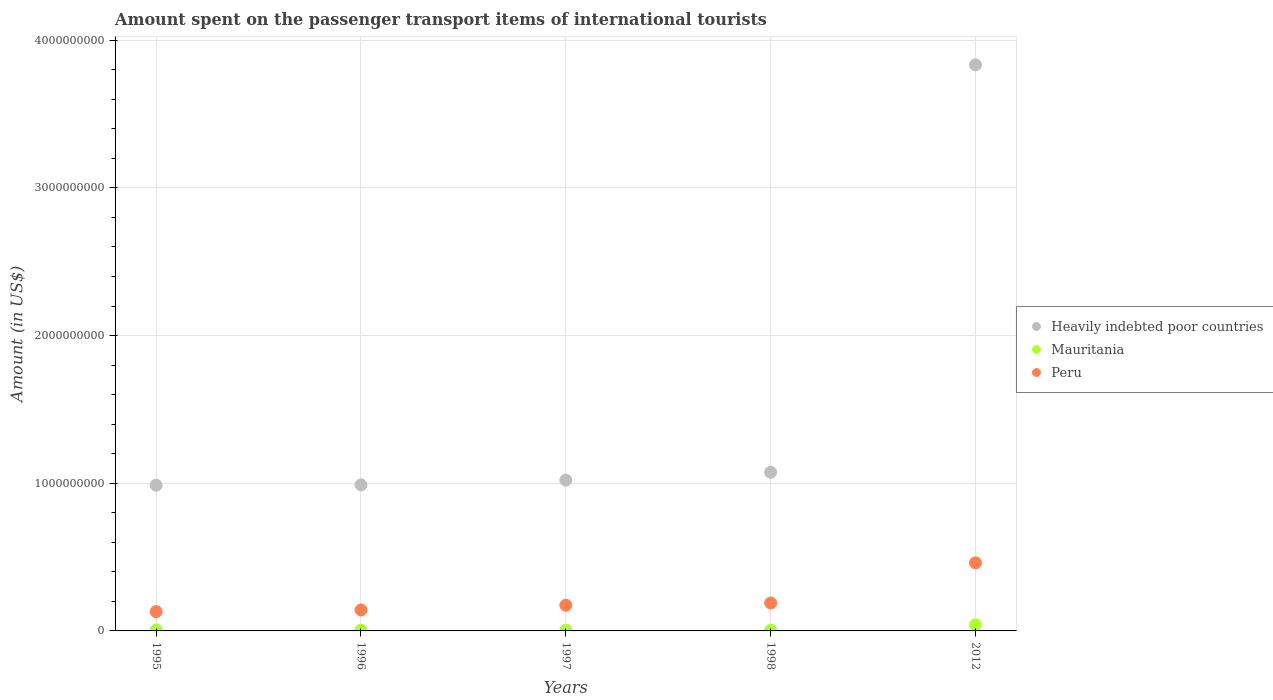How many different coloured dotlines are there?
Offer a terse response. 3. Is the number of dotlines equal to the number of legend labels?
Your answer should be very brief. Yes. What is the amount spent on the passenger transport items of international tourists in Heavily indebted poor countries in 1995?
Make the answer very short. 9.87e+08. Across all years, what is the maximum amount spent on the passenger transport items of international tourists in Mauritania?
Ensure brevity in your answer.  4.20e+07. Across all years, what is the minimum amount spent on the passenger transport items of international tourists in Peru?
Your answer should be compact. 1.31e+08. In which year was the amount spent on the passenger transport items of international tourists in Peru maximum?
Give a very brief answer. 2012. In which year was the amount spent on the passenger transport items of international tourists in Mauritania minimum?
Ensure brevity in your answer.  1996. What is the total amount spent on the passenger transport items of international tourists in Peru in the graph?
Ensure brevity in your answer.  1.10e+09. What is the difference between the amount spent on the passenger transport items of international tourists in Peru in 1995 and that in 1997?
Give a very brief answer. -4.30e+07. What is the difference between the amount spent on the passenger transport items of international tourists in Peru in 1997 and the amount spent on the passenger transport items of international tourists in Heavily indebted poor countries in 2012?
Make the answer very short. -3.66e+09. What is the average amount spent on the passenger transport items of international tourists in Peru per year?
Give a very brief answer. 2.19e+08. In the year 1997, what is the difference between the amount spent on the passenger transport items of international tourists in Peru and amount spent on the passenger transport items of international tourists in Heavily indebted poor countries?
Keep it short and to the point. -8.47e+08. Is the amount spent on the passenger transport items of international tourists in Heavily indebted poor countries in 1995 less than that in 1996?
Your response must be concise. Yes. What is the difference between the highest and the second highest amount spent on the passenger transport items of international tourists in Peru?
Offer a terse response. 2.72e+08. What is the difference between the highest and the lowest amount spent on the passenger transport items of international tourists in Heavily indebted poor countries?
Your response must be concise. 2.85e+09. In how many years, is the amount spent on the passenger transport items of international tourists in Heavily indebted poor countries greater than the average amount spent on the passenger transport items of international tourists in Heavily indebted poor countries taken over all years?
Offer a very short reply. 1. Is the amount spent on the passenger transport items of international tourists in Peru strictly greater than the amount spent on the passenger transport items of international tourists in Heavily indebted poor countries over the years?
Keep it short and to the point. No. How many years are there in the graph?
Offer a very short reply. 5. Are the values on the major ticks of Y-axis written in scientific E-notation?
Your response must be concise. No. Does the graph contain any zero values?
Keep it short and to the point. No. Does the graph contain grids?
Give a very brief answer. Yes. How many legend labels are there?
Give a very brief answer. 3. How are the legend labels stacked?
Keep it short and to the point. Vertical. What is the title of the graph?
Provide a short and direct response. Amount spent on the passenger transport items of international tourists. Does "Sri Lanka" appear as one of the legend labels in the graph?
Offer a very short reply. No. What is the label or title of the X-axis?
Offer a terse response. Years. What is the Amount (in US$) in Heavily indebted poor countries in 1995?
Provide a succinct answer. 9.87e+08. What is the Amount (in US$) in Peru in 1995?
Offer a very short reply. 1.31e+08. What is the Amount (in US$) of Heavily indebted poor countries in 1996?
Your response must be concise. 9.89e+08. What is the Amount (in US$) of Mauritania in 1996?
Provide a short and direct response. 5.00e+06. What is the Amount (in US$) in Peru in 1996?
Provide a succinct answer. 1.42e+08. What is the Amount (in US$) of Heavily indebted poor countries in 1997?
Offer a terse response. 1.02e+09. What is the Amount (in US$) in Peru in 1997?
Ensure brevity in your answer.  1.74e+08. What is the Amount (in US$) of Heavily indebted poor countries in 1998?
Make the answer very short. 1.07e+09. What is the Amount (in US$) of Mauritania in 1998?
Provide a succinct answer. 5.00e+06. What is the Amount (in US$) of Peru in 1998?
Make the answer very short. 1.89e+08. What is the Amount (in US$) of Heavily indebted poor countries in 2012?
Your answer should be very brief. 3.83e+09. What is the Amount (in US$) of Mauritania in 2012?
Your answer should be very brief. 4.20e+07. What is the Amount (in US$) in Peru in 2012?
Your response must be concise. 4.61e+08. Across all years, what is the maximum Amount (in US$) in Heavily indebted poor countries?
Offer a very short reply. 3.83e+09. Across all years, what is the maximum Amount (in US$) of Mauritania?
Provide a short and direct response. 4.20e+07. Across all years, what is the maximum Amount (in US$) in Peru?
Give a very brief answer. 4.61e+08. Across all years, what is the minimum Amount (in US$) in Heavily indebted poor countries?
Offer a terse response. 9.87e+08. Across all years, what is the minimum Amount (in US$) in Peru?
Your answer should be very brief. 1.31e+08. What is the total Amount (in US$) of Heavily indebted poor countries in the graph?
Ensure brevity in your answer.  7.90e+09. What is the total Amount (in US$) of Mauritania in the graph?
Ensure brevity in your answer.  6.40e+07. What is the total Amount (in US$) of Peru in the graph?
Offer a terse response. 1.10e+09. What is the difference between the Amount (in US$) in Heavily indebted poor countries in 1995 and that in 1996?
Ensure brevity in your answer.  -2.44e+06. What is the difference between the Amount (in US$) of Peru in 1995 and that in 1996?
Keep it short and to the point. -1.10e+07. What is the difference between the Amount (in US$) of Heavily indebted poor countries in 1995 and that in 1997?
Keep it short and to the point. -3.46e+07. What is the difference between the Amount (in US$) of Peru in 1995 and that in 1997?
Provide a succinct answer. -4.30e+07. What is the difference between the Amount (in US$) of Heavily indebted poor countries in 1995 and that in 1998?
Offer a terse response. -8.73e+07. What is the difference between the Amount (in US$) of Mauritania in 1995 and that in 1998?
Your answer should be very brief. 2.00e+06. What is the difference between the Amount (in US$) of Peru in 1995 and that in 1998?
Ensure brevity in your answer.  -5.80e+07. What is the difference between the Amount (in US$) in Heavily indebted poor countries in 1995 and that in 2012?
Provide a short and direct response. -2.85e+09. What is the difference between the Amount (in US$) in Mauritania in 1995 and that in 2012?
Provide a short and direct response. -3.50e+07. What is the difference between the Amount (in US$) in Peru in 1995 and that in 2012?
Provide a short and direct response. -3.30e+08. What is the difference between the Amount (in US$) of Heavily indebted poor countries in 1996 and that in 1997?
Give a very brief answer. -3.21e+07. What is the difference between the Amount (in US$) of Mauritania in 1996 and that in 1997?
Give a very brief answer. 0. What is the difference between the Amount (in US$) of Peru in 1996 and that in 1997?
Provide a short and direct response. -3.20e+07. What is the difference between the Amount (in US$) of Heavily indebted poor countries in 1996 and that in 1998?
Ensure brevity in your answer.  -8.49e+07. What is the difference between the Amount (in US$) of Mauritania in 1996 and that in 1998?
Keep it short and to the point. 0. What is the difference between the Amount (in US$) of Peru in 1996 and that in 1998?
Ensure brevity in your answer.  -4.70e+07. What is the difference between the Amount (in US$) in Heavily indebted poor countries in 1996 and that in 2012?
Offer a terse response. -2.84e+09. What is the difference between the Amount (in US$) in Mauritania in 1996 and that in 2012?
Provide a succinct answer. -3.70e+07. What is the difference between the Amount (in US$) in Peru in 1996 and that in 2012?
Make the answer very short. -3.19e+08. What is the difference between the Amount (in US$) in Heavily indebted poor countries in 1997 and that in 1998?
Your answer should be very brief. -5.28e+07. What is the difference between the Amount (in US$) of Peru in 1997 and that in 1998?
Ensure brevity in your answer.  -1.50e+07. What is the difference between the Amount (in US$) of Heavily indebted poor countries in 1997 and that in 2012?
Provide a short and direct response. -2.81e+09. What is the difference between the Amount (in US$) of Mauritania in 1997 and that in 2012?
Provide a succinct answer. -3.70e+07. What is the difference between the Amount (in US$) of Peru in 1997 and that in 2012?
Offer a very short reply. -2.87e+08. What is the difference between the Amount (in US$) of Heavily indebted poor countries in 1998 and that in 2012?
Ensure brevity in your answer.  -2.76e+09. What is the difference between the Amount (in US$) in Mauritania in 1998 and that in 2012?
Offer a very short reply. -3.70e+07. What is the difference between the Amount (in US$) of Peru in 1998 and that in 2012?
Your answer should be compact. -2.72e+08. What is the difference between the Amount (in US$) in Heavily indebted poor countries in 1995 and the Amount (in US$) in Mauritania in 1996?
Your response must be concise. 9.82e+08. What is the difference between the Amount (in US$) of Heavily indebted poor countries in 1995 and the Amount (in US$) of Peru in 1996?
Your answer should be compact. 8.45e+08. What is the difference between the Amount (in US$) of Mauritania in 1995 and the Amount (in US$) of Peru in 1996?
Make the answer very short. -1.35e+08. What is the difference between the Amount (in US$) in Heavily indebted poor countries in 1995 and the Amount (in US$) in Mauritania in 1997?
Your answer should be very brief. 9.82e+08. What is the difference between the Amount (in US$) of Heavily indebted poor countries in 1995 and the Amount (in US$) of Peru in 1997?
Offer a very short reply. 8.13e+08. What is the difference between the Amount (in US$) of Mauritania in 1995 and the Amount (in US$) of Peru in 1997?
Your answer should be compact. -1.67e+08. What is the difference between the Amount (in US$) in Heavily indebted poor countries in 1995 and the Amount (in US$) in Mauritania in 1998?
Provide a short and direct response. 9.82e+08. What is the difference between the Amount (in US$) in Heavily indebted poor countries in 1995 and the Amount (in US$) in Peru in 1998?
Make the answer very short. 7.98e+08. What is the difference between the Amount (in US$) in Mauritania in 1995 and the Amount (in US$) in Peru in 1998?
Give a very brief answer. -1.82e+08. What is the difference between the Amount (in US$) of Heavily indebted poor countries in 1995 and the Amount (in US$) of Mauritania in 2012?
Ensure brevity in your answer.  9.45e+08. What is the difference between the Amount (in US$) of Heavily indebted poor countries in 1995 and the Amount (in US$) of Peru in 2012?
Your answer should be compact. 5.26e+08. What is the difference between the Amount (in US$) in Mauritania in 1995 and the Amount (in US$) in Peru in 2012?
Your answer should be compact. -4.54e+08. What is the difference between the Amount (in US$) of Heavily indebted poor countries in 1996 and the Amount (in US$) of Mauritania in 1997?
Give a very brief answer. 9.84e+08. What is the difference between the Amount (in US$) of Heavily indebted poor countries in 1996 and the Amount (in US$) of Peru in 1997?
Offer a very short reply. 8.15e+08. What is the difference between the Amount (in US$) in Mauritania in 1996 and the Amount (in US$) in Peru in 1997?
Your answer should be compact. -1.69e+08. What is the difference between the Amount (in US$) in Heavily indebted poor countries in 1996 and the Amount (in US$) in Mauritania in 1998?
Your response must be concise. 9.84e+08. What is the difference between the Amount (in US$) of Heavily indebted poor countries in 1996 and the Amount (in US$) of Peru in 1998?
Provide a short and direct response. 8.00e+08. What is the difference between the Amount (in US$) of Mauritania in 1996 and the Amount (in US$) of Peru in 1998?
Ensure brevity in your answer.  -1.84e+08. What is the difference between the Amount (in US$) of Heavily indebted poor countries in 1996 and the Amount (in US$) of Mauritania in 2012?
Give a very brief answer. 9.47e+08. What is the difference between the Amount (in US$) of Heavily indebted poor countries in 1996 and the Amount (in US$) of Peru in 2012?
Give a very brief answer. 5.28e+08. What is the difference between the Amount (in US$) in Mauritania in 1996 and the Amount (in US$) in Peru in 2012?
Your answer should be very brief. -4.56e+08. What is the difference between the Amount (in US$) of Heavily indebted poor countries in 1997 and the Amount (in US$) of Mauritania in 1998?
Provide a succinct answer. 1.02e+09. What is the difference between the Amount (in US$) in Heavily indebted poor countries in 1997 and the Amount (in US$) in Peru in 1998?
Offer a very short reply. 8.32e+08. What is the difference between the Amount (in US$) of Mauritania in 1997 and the Amount (in US$) of Peru in 1998?
Your response must be concise. -1.84e+08. What is the difference between the Amount (in US$) of Heavily indebted poor countries in 1997 and the Amount (in US$) of Mauritania in 2012?
Offer a terse response. 9.79e+08. What is the difference between the Amount (in US$) in Heavily indebted poor countries in 1997 and the Amount (in US$) in Peru in 2012?
Offer a very short reply. 5.60e+08. What is the difference between the Amount (in US$) of Mauritania in 1997 and the Amount (in US$) of Peru in 2012?
Provide a succinct answer. -4.56e+08. What is the difference between the Amount (in US$) of Heavily indebted poor countries in 1998 and the Amount (in US$) of Mauritania in 2012?
Ensure brevity in your answer.  1.03e+09. What is the difference between the Amount (in US$) in Heavily indebted poor countries in 1998 and the Amount (in US$) in Peru in 2012?
Ensure brevity in your answer.  6.13e+08. What is the difference between the Amount (in US$) of Mauritania in 1998 and the Amount (in US$) of Peru in 2012?
Provide a short and direct response. -4.56e+08. What is the average Amount (in US$) in Heavily indebted poor countries per year?
Ensure brevity in your answer.  1.58e+09. What is the average Amount (in US$) in Mauritania per year?
Keep it short and to the point. 1.28e+07. What is the average Amount (in US$) of Peru per year?
Give a very brief answer. 2.19e+08. In the year 1995, what is the difference between the Amount (in US$) in Heavily indebted poor countries and Amount (in US$) in Mauritania?
Your answer should be very brief. 9.80e+08. In the year 1995, what is the difference between the Amount (in US$) of Heavily indebted poor countries and Amount (in US$) of Peru?
Provide a succinct answer. 8.56e+08. In the year 1995, what is the difference between the Amount (in US$) in Mauritania and Amount (in US$) in Peru?
Ensure brevity in your answer.  -1.24e+08. In the year 1996, what is the difference between the Amount (in US$) in Heavily indebted poor countries and Amount (in US$) in Mauritania?
Your response must be concise. 9.84e+08. In the year 1996, what is the difference between the Amount (in US$) in Heavily indebted poor countries and Amount (in US$) in Peru?
Give a very brief answer. 8.47e+08. In the year 1996, what is the difference between the Amount (in US$) of Mauritania and Amount (in US$) of Peru?
Offer a terse response. -1.37e+08. In the year 1997, what is the difference between the Amount (in US$) in Heavily indebted poor countries and Amount (in US$) in Mauritania?
Ensure brevity in your answer.  1.02e+09. In the year 1997, what is the difference between the Amount (in US$) of Heavily indebted poor countries and Amount (in US$) of Peru?
Provide a short and direct response. 8.47e+08. In the year 1997, what is the difference between the Amount (in US$) of Mauritania and Amount (in US$) of Peru?
Your response must be concise. -1.69e+08. In the year 1998, what is the difference between the Amount (in US$) in Heavily indebted poor countries and Amount (in US$) in Mauritania?
Your response must be concise. 1.07e+09. In the year 1998, what is the difference between the Amount (in US$) of Heavily indebted poor countries and Amount (in US$) of Peru?
Provide a succinct answer. 8.85e+08. In the year 1998, what is the difference between the Amount (in US$) of Mauritania and Amount (in US$) of Peru?
Offer a terse response. -1.84e+08. In the year 2012, what is the difference between the Amount (in US$) of Heavily indebted poor countries and Amount (in US$) of Mauritania?
Your answer should be compact. 3.79e+09. In the year 2012, what is the difference between the Amount (in US$) of Heavily indebted poor countries and Amount (in US$) of Peru?
Your answer should be compact. 3.37e+09. In the year 2012, what is the difference between the Amount (in US$) in Mauritania and Amount (in US$) in Peru?
Your answer should be compact. -4.19e+08. What is the ratio of the Amount (in US$) in Mauritania in 1995 to that in 1996?
Your response must be concise. 1.4. What is the ratio of the Amount (in US$) in Peru in 1995 to that in 1996?
Make the answer very short. 0.92. What is the ratio of the Amount (in US$) in Heavily indebted poor countries in 1995 to that in 1997?
Keep it short and to the point. 0.97. What is the ratio of the Amount (in US$) in Peru in 1995 to that in 1997?
Offer a very short reply. 0.75. What is the ratio of the Amount (in US$) in Heavily indebted poor countries in 1995 to that in 1998?
Provide a short and direct response. 0.92. What is the ratio of the Amount (in US$) in Mauritania in 1995 to that in 1998?
Make the answer very short. 1.4. What is the ratio of the Amount (in US$) in Peru in 1995 to that in 1998?
Provide a short and direct response. 0.69. What is the ratio of the Amount (in US$) in Heavily indebted poor countries in 1995 to that in 2012?
Give a very brief answer. 0.26. What is the ratio of the Amount (in US$) in Mauritania in 1995 to that in 2012?
Make the answer very short. 0.17. What is the ratio of the Amount (in US$) of Peru in 1995 to that in 2012?
Your answer should be compact. 0.28. What is the ratio of the Amount (in US$) in Heavily indebted poor countries in 1996 to that in 1997?
Your answer should be compact. 0.97. What is the ratio of the Amount (in US$) in Mauritania in 1996 to that in 1997?
Provide a short and direct response. 1. What is the ratio of the Amount (in US$) in Peru in 1996 to that in 1997?
Give a very brief answer. 0.82. What is the ratio of the Amount (in US$) of Heavily indebted poor countries in 1996 to that in 1998?
Give a very brief answer. 0.92. What is the ratio of the Amount (in US$) of Mauritania in 1996 to that in 1998?
Provide a succinct answer. 1. What is the ratio of the Amount (in US$) in Peru in 1996 to that in 1998?
Your answer should be compact. 0.75. What is the ratio of the Amount (in US$) of Heavily indebted poor countries in 1996 to that in 2012?
Make the answer very short. 0.26. What is the ratio of the Amount (in US$) of Mauritania in 1996 to that in 2012?
Your answer should be very brief. 0.12. What is the ratio of the Amount (in US$) in Peru in 1996 to that in 2012?
Provide a succinct answer. 0.31. What is the ratio of the Amount (in US$) in Heavily indebted poor countries in 1997 to that in 1998?
Your answer should be compact. 0.95. What is the ratio of the Amount (in US$) in Peru in 1997 to that in 1998?
Make the answer very short. 0.92. What is the ratio of the Amount (in US$) in Heavily indebted poor countries in 1997 to that in 2012?
Give a very brief answer. 0.27. What is the ratio of the Amount (in US$) in Mauritania in 1997 to that in 2012?
Keep it short and to the point. 0.12. What is the ratio of the Amount (in US$) of Peru in 1997 to that in 2012?
Ensure brevity in your answer.  0.38. What is the ratio of the Amount (in US$) of Heavily indebted poor countries in 1998 to that in 2012?
Your response must be concise. 0.28. What is the ratio of the Amount (in US$) of Mauritania in 1998 to that in 2012?
Offer a very short reply. 0.12. What is the ratio of the Amount (in US$) of Peru in 1998 to that in 2012?
Offer a terse response. 0.41. What is the difference between the highest and the second highest Amount (in US$) in Heavily indebted poor countries?
Offer a terse response. 2.76e+09. What is the difference between the highest and the second highest Amount (in US$) in Mauritania?
Ensure brevity in your answer.  3.50e+07. What is the difference between the highest and the second highest Amount (in US$) in Peru?
Your answer should be very brief. 2.72e+08. What is the difference between the highest and the lowest Amount (in US$) in Heavily indebted poor countries?
Give a very brief answer. 2.85e+09. What is the difference between the highest and the lowest Amount (in US$) in Mauritania?
Keep it short and to the point. 3.70e+07. What is the difference between the highest and the lowest Amount (in US$) of Peru?
Offer a terse response. 3.30e+08. 